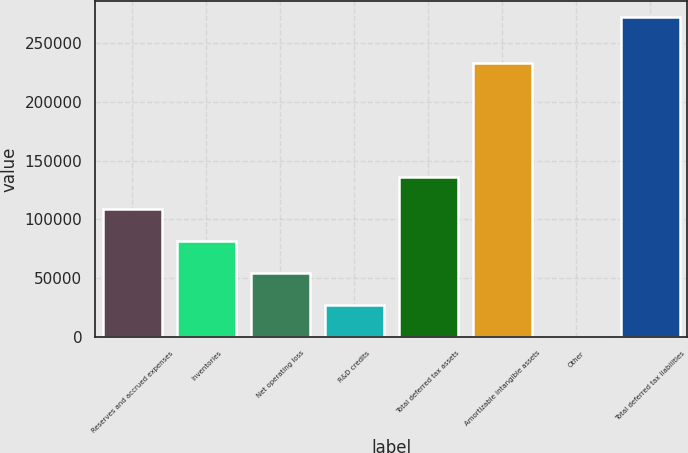<chart> <loc_0><loc_0><loc_500><loc_500><bar_chart><fcel>Reserves and accrued expenses<fcel>Inventories<fcel>Net operating loss<fcel>R&D credits<fcel>Total deferred tax assets<fcel>Amortizable intangible assets<fcel>Other<fcel>Total deferred tax liabilities<nl><fcel>109001<fcel>81803.7<fcel>54606.8<fcel>27409.9<fcel>136198<fcel>233130<fcel>213<fcel>272182<nl></chart> 